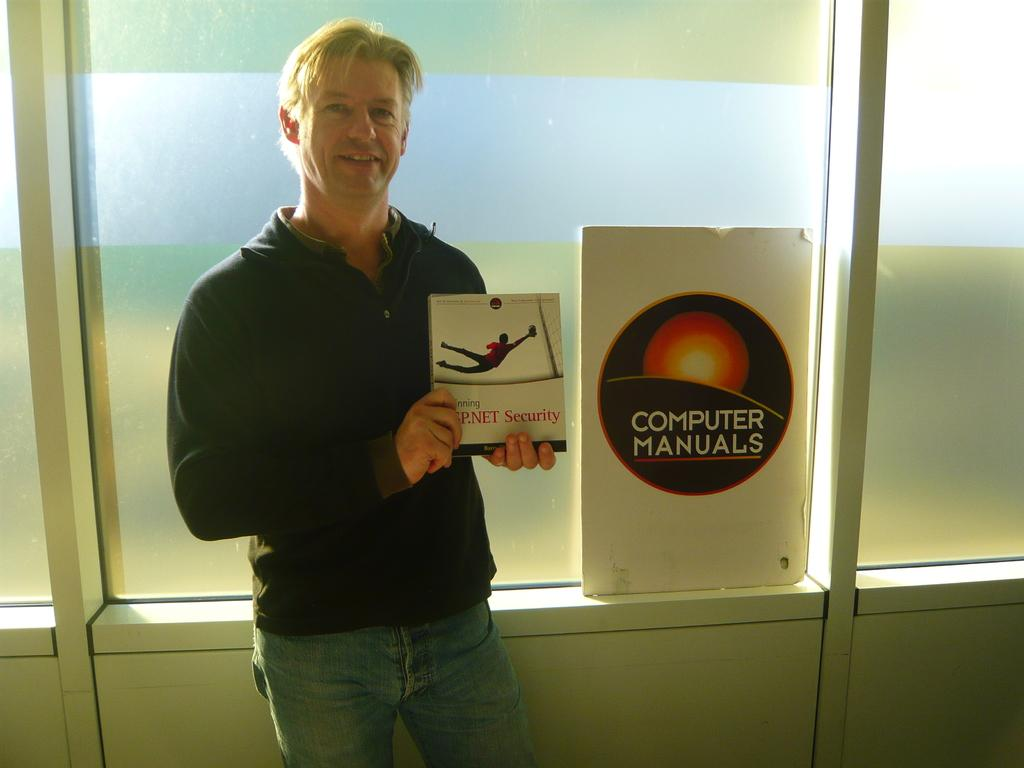<image>
Write a terse but informative summary of the picture. A man holds up a book while standing next to a Computer Manuals sign. 